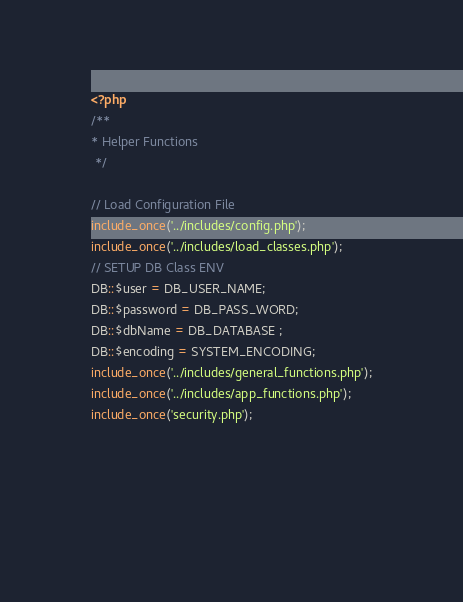<code> <loc_0><loc_0><loc_500><loc_500><_PHP_><?php
/**
* Helper Functions
 */

// Load Configuration File
include_once('../includes/config.php');
include_once('../includes/load_classes.php');
// SETUP DB Class ENV 
DB::$user = DB_USER_NAME;
DB::$password = DB_PASS_WORD;
DB::$dbName = DB_DATABASE ;
DB::$encoding = SYSTEM_ENCODING;
include_once('../includes/general_functions.php');
include_once('../includes/app_functions.php');
include_once('security.php'); 

 

 </code> 